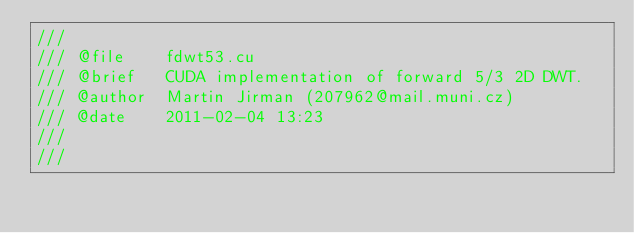Convert code to text. <code><loc_0><loc_0><loc_500><loc_500><_Cuda_>/// 
/// @file    fdwt53.cu
/// @brief   CUDA implementation of forward 5/3 2D DWT.
/// @author  Martin Jirman (207962@mail.muni.cz)
/// @date    2011-02-04 13:23
///
///</code> 